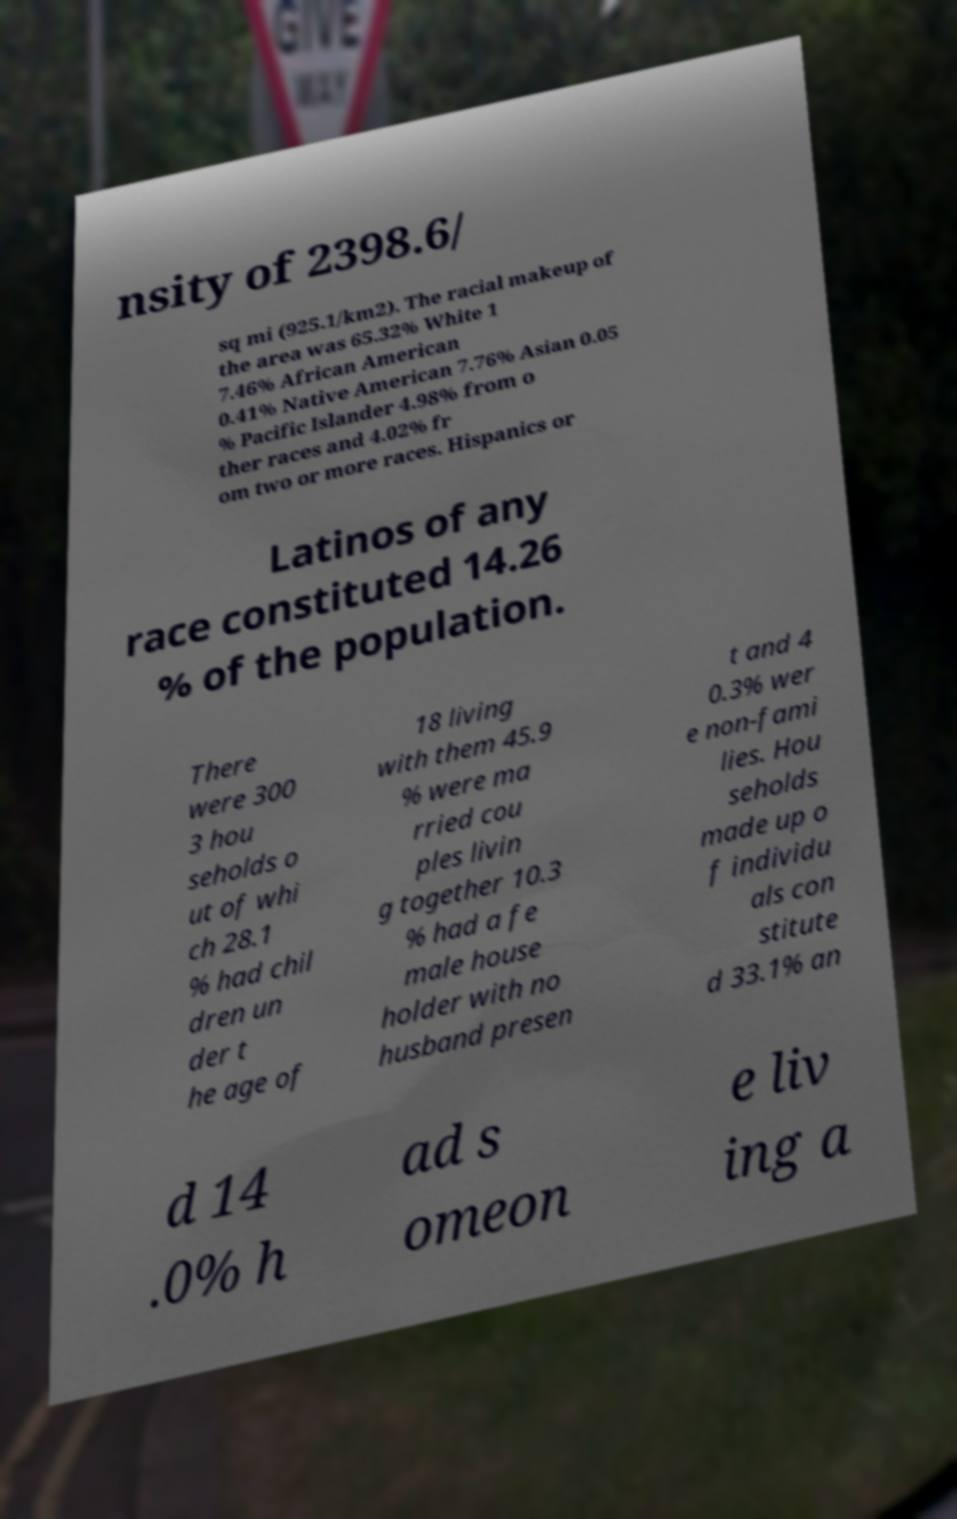Can you accurately transcribe the text from the provided image for me? nsity of 2398.6/ sq mi (925.1/km2). The racial makeup of the area was 65.32% White 1 7.46% African American 0.41% Native American 7.76% Asian 0.05 % Pacific Islander 4.98% from o ther races and 4.02% fr om two or more races. Hispanics or Latinos of any race constituted 14.26 % of the population. There were 300 3 hou seholds o ut of whi ch 28.1 % had chil dren un der t he age of 18 living with them 45.9 % were ma rried cou ples livin g together 10.3 % had a fe male house holder with no husband presen t and 4 0.3% wer e non-fami lies. Hou seholds made up o f individu als con stitute d 33.1% an d 14 .0% h ad s omeon e liv ing a 